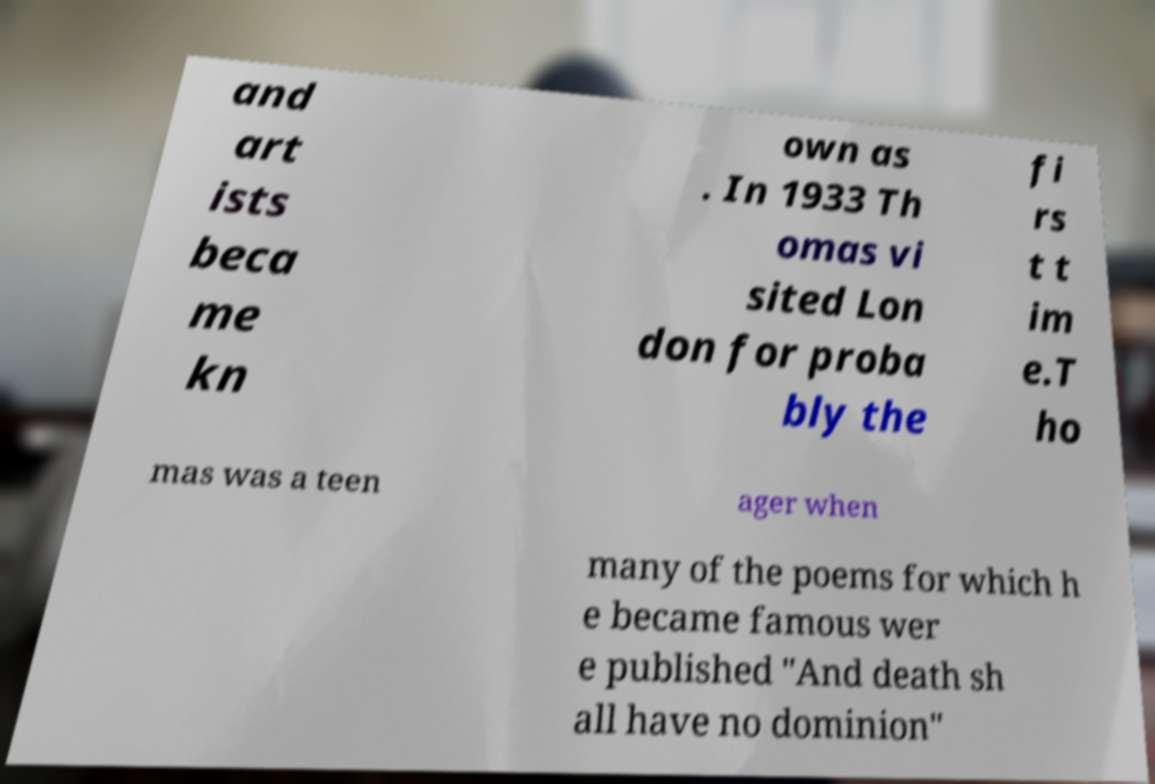Please identify and transcribe the text found in this image. and art ists beca me kn own as . In 1933 Th omas vi sited Lon don for proba bly the fi rs t t im e.T ho mas was a teen ager when many of the poems for which h e became famous wer e published "And death sh all have no dominion" 